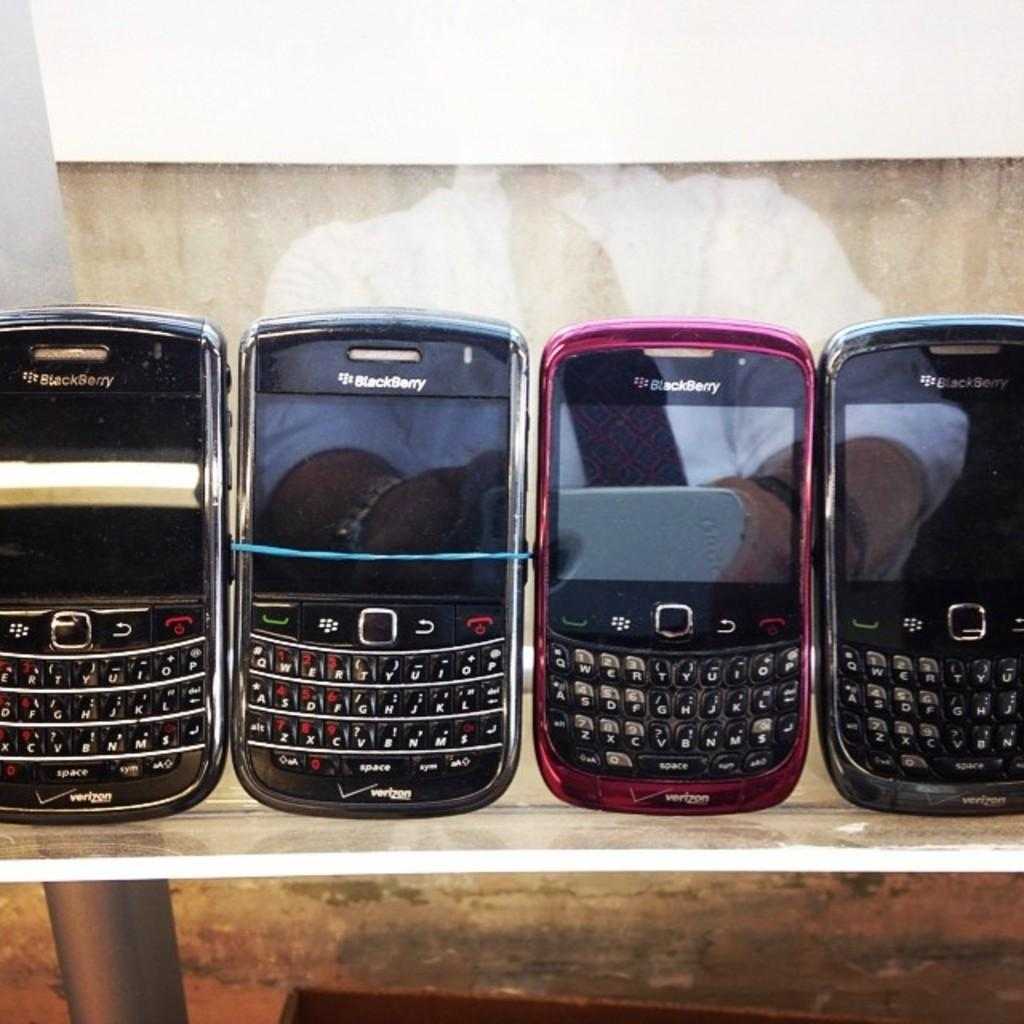<image>
Offer a succinct explanation of the picture presented. Different color Blackberry devices are lined up on a glass table. 